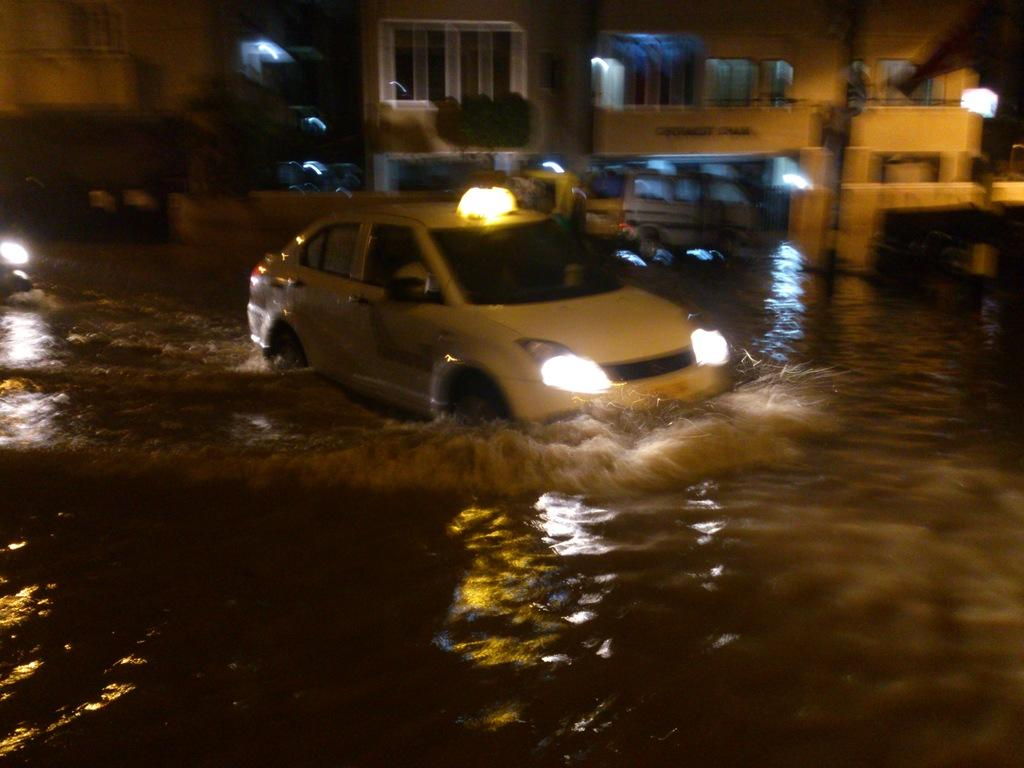What is the primary element in the image? There is water in the image. What is happening in the water? A car is moving in the water. What can be seen in the background of the image? There are buildings and lights visible in the image. Are there any other vehicles present in the image? Yes, there is another car in the background of the image. What type of office can be seen in the image? There is no office present in the image. Are there any dinosaurs visible in the image? There are no dinosaurs present in the image. 